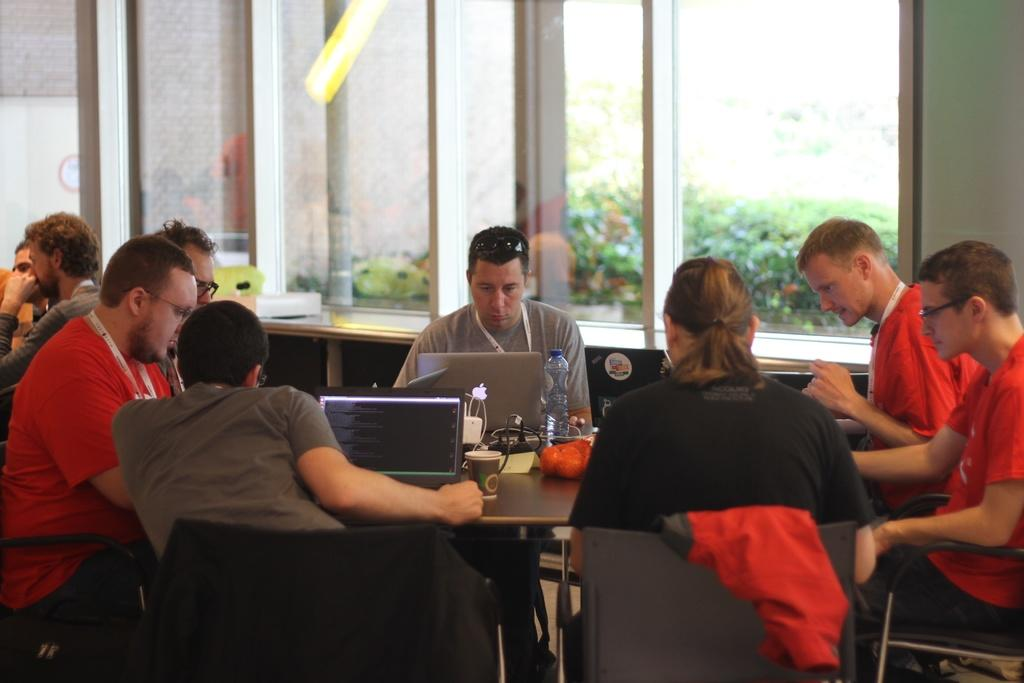What are the people in the image doing? The people in the image are operating laptops. What can be seen on the tables in the image? There are glasses and a bottle on the tables. What is visible through the window in the image? Trees are visible outside the building through the window. How many babies are playing with a toy under the umbrella in the image? There are no babies, toys, or umbrellas present in the image. 